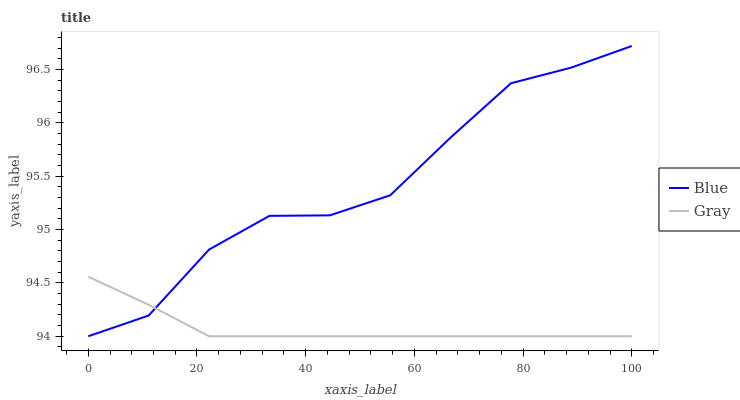Does Gray have the minimum area under the curve?
Answer yes or no. Yes. Does Blue have the maximum area under the curve?
Answer yes or no. Yes. Does Gray have the maximum area under the curve?
Answer yes or no. No. Is Gray the smoothest?
Answer yes or no. Yes. Is Blue the roughest?
Answer yes or no. Yes. Is Gray the roughest?
Answer yes or no. No. Does Blue have the highest value?
Answer yes or no. Yes. Does Gray have the highest value?
Answer yes or no. No. Does Gray intersect Blue?
Answer yes or no. Yes. Is Gray less than Blue?
Answer yes or no. No. Is Gray greater than Blue?
Answer yes or no. No. 